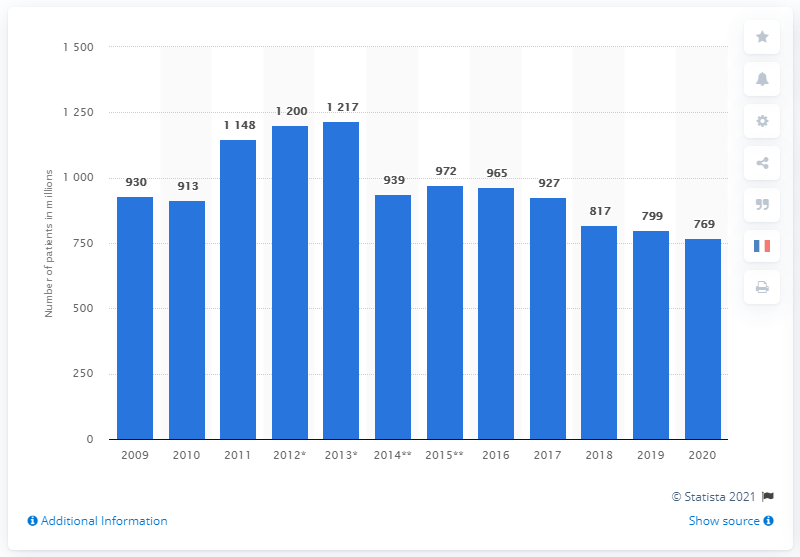Outline some significant characteristics in this image. In 2012, Novartis reached a total of 1,200 patients with its healthcare services. 